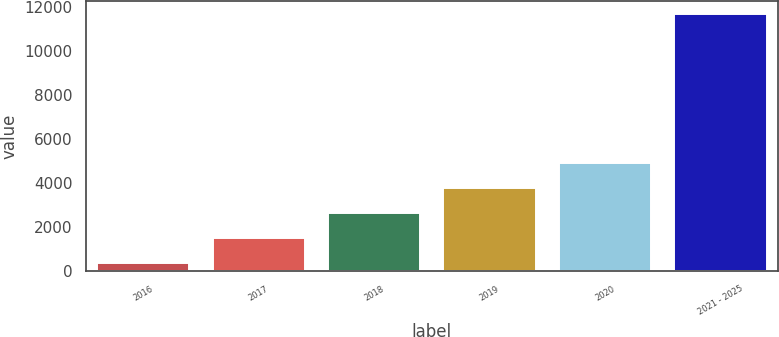Convert chart to OTSL. <chart><loc_0><loc_0><loc_500><loc_500><bar_chart><fcel>2016<fcel>2017<fcel>2018<fcel>2019<fcel>2020<fcel>2021 - 2025<nl><fcel>381<fcel>1510.1<fcel>2639.2<fcel>3768.3<fcel>4897.4<fcel>11672<nl></chart> 